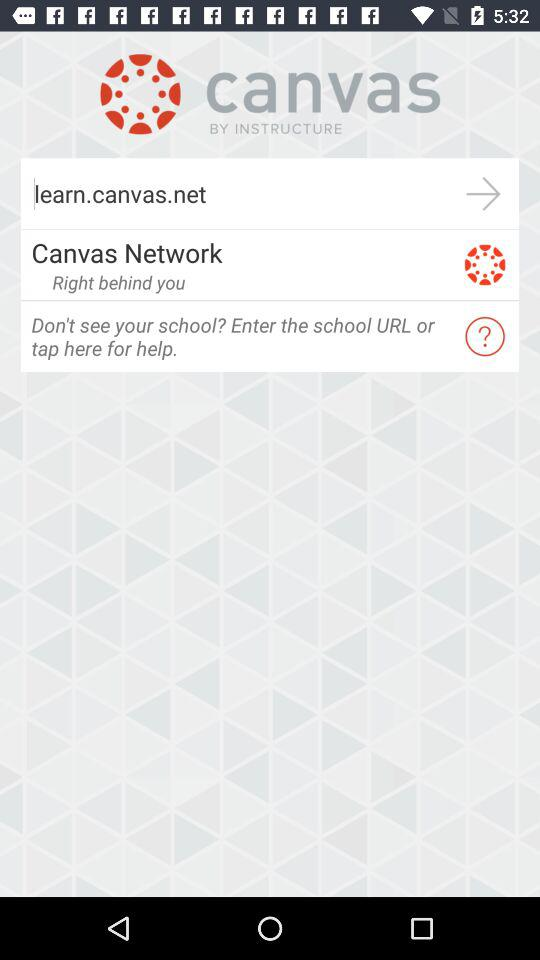What is the website? The website is learn.canvas.net. 